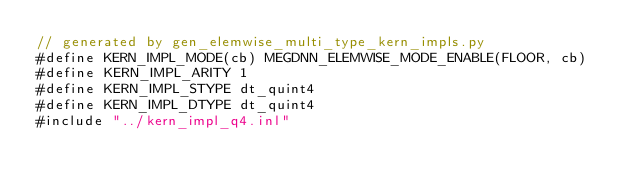Convert code to text. <code><loc_0><loc_0><loc_500><loc_500><_Cuda_>// generated by gen_elemwise_multi_type_kern_impls.py
#define KERN_IMPL_MODE(cb) MEGDNN_ELEMWISE_MODE_ENABLE(FLOOR, cb)
#define KERN_IMPL_ARITY 1
#define KERN_IMPL_STYPE dt_quint4
#define KERN_IMPL_DTYPE dt_quint4
#include "../kern_impl_q4.inl"
</code> 